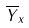Convert formula to latex. <formula><loc_0><loc_0><loc_500><loc_500>\overline { Y } _ { x }</formula> 